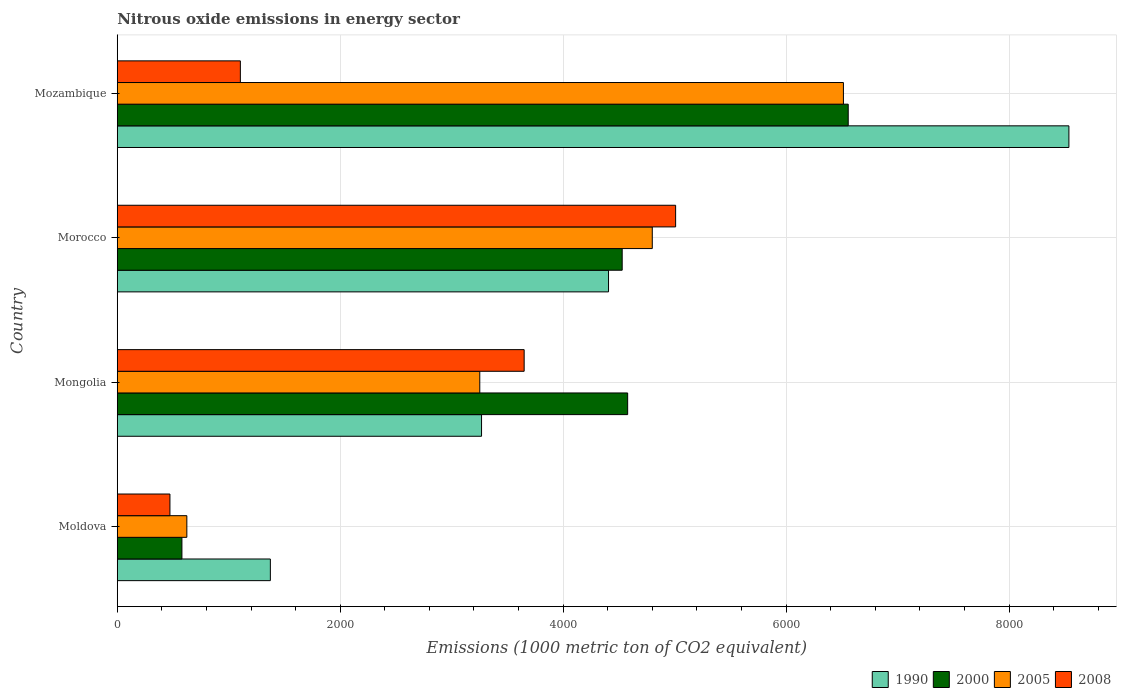Are the number of bars per tick equal to the number of legend labels?
Your answer should be compact. Yes. How many bars are there on the 3rd tick from the bottom?
Make the answer very short. 4. What is the label of the 1st group of bars from the top?
Provide a short and direct response. Mozambique. In how many cases, is the number of bars for a given country not equal to the number of legend labels?
Provide a succinct answer. 0. What is the amount of nitrous oxide emitted in 2008 in Moldova?
Your response must be concise. 472.4. Across all countries, what is the maximum amount of nitrous oxide emitted in 2005?
Your answer should be very brief. 6514.2. Across all countries, what is the minimum amount of nitrous oxide emitted in 1990?
Offer a terse response. 1373.3. In which country was the amount of nitrous oxide emitted in 2005 maximum?
Keep it short and to the point. Mozambique. In which country was the amount of nitrous oxide emitted in 1990 minimum?
Provide a short and direct response. Moldova. What is the total amount of nitrous oxide emitted in 2005 in the graph?
Offer a very short reply. 1.52e+04. What is the difference between the amount of nitrous oxide emitted in 1990 in Moldova and that in Mozambique?
Offer a terse response. -7163.7. What is the difference between the amount of nitrous oxide emitted in 2008 in Morocco and the amount of nitrous oxide emitted in 1990 in Mongolia?
Provide a short and direct response. 1741.1. What is the average amount of nitrous oxide emitted in 2000 per country?
Provide a short and direct response. 4061.3. What is the difference between the amount of nitrous oxide emitted in 1990 and amount of nitrous oxide emitted in 2000 in Mongolia?
Your response must be concise. -1310.8. What is the ratio of the amount of nitrous oxide emitted in 2008 in Mongolia to that in Morocco?
Keep it short and to the point. 0.73. Is the difference between the amount of nitrous oxide emitted in 1990 in Moldova and Mongolia greater than the difference between the amount of nitrous oxide emitted in 2000 in Moldova and Mongolia?
Your response must be concise. Yes. What is the difference between the highest and the second highest amount of nitrous oxide emitted in 2000?
Offer a very short reply. 1978.6. What is the difference between the highest and the lowest amount of nitrous oxide emitted in 2008?
Offer a very short reply. 4536.5. In how many countries, is the amount of nitrous oxide emitted in 2000 greater than the average amount of nitrous oxide emitted in 2000 taken over all countries?
Ensure brevity in your answer.  3. Is the sum of the amount of nitrous oxide emitted in 2008 in Moldova and Mozambique greater than the maximum amount of nitrous oxide emitted in 1990 across all countries?
Give a very brief answer. No. Is it the case that in every country, the sum of the amount of nitrous oxide emitted in 2000 and amount of nitrous oxide emitted in 1990 is greater than the sum of amount of nitrous oxide emitted in 2005 and amount of nitrous oxide emitted in 2008?
Provide a succinct answer. No. What does the 1st bar from the bottom in Moldova represents?
Make the answer very short. 1990. What is the difference between two consecutive major ticks on the X-axis?
Your response must be concise. 2000. Are the values on the major ticks of X-axis written in scientific E-notation?
Offer a terse response. No. Does the graph contain any zero values?
Ensure brevity in your answer.  No. Does the graph contain grids?
Offer a terse response. Yes. What is the title of the graph?
Make the answer very short. Nitrous oxide emissions in energy sector. What is the label or title of the X-axis?
Provide a short and direct response. Emissions (1000 metric ton of CO2 equivalent). What is the Emissions (1000 metric ton of CO2 equivalent) of 1990 in Moldova?
Offer a terse response. 1373.3. What is the Emissions (1000 metric ton of CO2 equivalent) in 2000 in Moldova?
Your response must be concise. 579.9. What is the Emissions (1000 metric ton of CO2 equivalent) of 2005 in Moldova?
Give a very brief answer. 624.1. What is the Emissions (1000 metric ton of CO2 equivalent) in 2008 in Moldova?
Give a very brief answer. 472.4. What is the Emissions (1000 metric ton of CO2 equivalent) of 1990 in Mongolia?
Provide a short and direct response. 3267.8. What is the Emissions (1000 metric ton of CO2 equivalent) of 2000 in Mongolia?
Your answer should be compact. 4578.6. What is the Emissions (1000 metric ton of CO2 equivalent) in 2005 in Mongolia?
Offer a very short reply. 3251.9. What is the Emissions (1000 metric ton of CO2 equivalent) in 2008 in Mongolia?
Make the answer very short. 3650.1. What is the Emissions (1000 metric ton of CO2 equivalent) of 1990 in Morocco?
Offer a very short reply. 4406.9. What is the Emissions (1000 metric ton of CO2 equivalent) of 2000 in Morocco?
Your answer should be very brief. 4529.5. What is the Emissions (1000 metric ton of CO2 equivalent) in 2005 in Morocco?
Your answer should be very brief. 4799.4. What is the Emissions (1000 metric ton of CO2 equivalent) in 2008 in Morocco?
Your answer should be very brief. 5008.9. What is the Emissions (1000 metric ton of CO2 equivalent) of 1990 in Mozambique?
Give a very brief answer. 8537. What is the Emissions (1000 metric ton of CO2 equivalent) in 2000 in Mozambique?
Keep it short and to the point. 6557.2. What is the Emissions (1000 metric ton of CO2 equivalent) in 2005 in Mozambique?
Give a very brief answer. 6514.2. What is the Emissions (1000 metric ton of CO2 equivalent) of 2008 in Mozambique?
Your response must be concise. 1104.1. Across all countries, what is the maximum Emissions (1000 metric ton of CO2 equivalent) of 1990?
Provide a short and direct response. 8537. Across all countries, what is the maximum Emissions (1000 metric ton of CO2 equivalent) of 2000?
Provide a short and direct response. 6557.2. Across all countries, what is the maximum Emissions (1000 metric ton of CO2 equivalent) in 2005?
Give a very brief answer. 6514.2. Across all countries, what is the maximum Emissions (1000 metric ton of CO2 equivalent) of 2008?
Give a very brief answer. 5008.9. Across all countries, what is the minimum Emissions (1000 metric ton of CO2 equivalent) in 1990?
Your response must be concise. 1373.3. Across all countries, what is the minimum Emissions (1000 metric ton of CO2 equivalent) of 2000?
Provide a short and direct response. 579.9. Across all countries, what is the minimum Emissions (1000 metric ton of CO2 equivalent) of 2005?
Offer a very short reply. 624.1. Across all countries, what is the minimum Emissions (1000 metric ton of CO2 equivalent) of 2008?
Keep it short and to the point. 472.4. What is the total Emissions (1000 metric ton of CO2 equivalent) of 1990 in the graph?
Make the answer very short. 1.76e+04. What is the total Emissions (1000 metric ton of CO2 equivalent) of 2000 in the graph?
Provide a short and direct response. 1.62e+04. What is the total Emissions (1000 metric ton of CO2 equivalent) in 2005 in the graph?
Your answer should be compact. 1.52e+04. What is the total Emissions (1000 metric ton of CO2 equivalent) of 2008 in the graph?
Your answer should be compact. 1.02e+04. What is the difference between the Emissions (1000 metric ton of CO2 equivalent) of 1990 in Moldova and that in Mongolia?
Offer a terse response. -1894.5. What is the difference between the Emissions (1000 metric ton of CO2 equivalent) in 2000 in Moldova and that in Mongolia?
Make the answer very short. -3998.7. What is the difference between the Emissions (1000 metric ton of CO2 equivalent) in 2005 in Moldova and that in Mongolia?
Your response must be concise. -2627.8. What is the difference between the Emissions (1000 metric ton of CO2 equivalent) in 2008 in Moldova and that in Mongolia?
Your answer should be compact. -3177.7. What is the difference between the Emissions (1000 metric ton of CO2 equivalent) of 1990 in Moldova and that in Morocco?
Offer a very short reply. -3033.6. What is the difference between the Emissions (1000 metric ton of CO2 equivalent) of 2000 in Moldova and that in Morocco?
Your answer should be compact. -3949.6. What is the difference between the Emissions (1000 metric ton of CO2 equivalent) of 2005 in Moldova and that in Morocco?
Give a very brief answer. -4175.3. What is the difference between the Emissions (1000 metric ton of CO2 equivalent) in 2008 in Moldova and that in Morocco?
Make the answer very short. -4536.5. What is the difference between the Emissions (1000 metric ton of CO2 equivalent) in 1990 in Moldova and that in Mozambique?
Give a very brief answer. -7163.7. What is the difference between the Emissions (1000 metric ton of CO2 equivalent) of 2000 in Moldova and that in Mozambique?
Your answer should be compact. -5977.3. What is the difference between the Emissions (1000 metric ton of CO2 equivalent) in 2005 in Moldova and that in Mozambique?
Your response must be concise. -5890.1. What is the difference between the Emissions (1000 metric ton of CO2 equivalent) of 2008 in Moldova and that in Mozambique?
Offer a very short reply. -631.7. What is the difference between the Emissions (1000 metric ton of CO2 equivalent) in 1990 in Mongolia and that in Morocco?
Offer a terse response. -1139.1. What is the difference between the Emissions (1000 metric ton of CO2 equivalent) in 2000 in Mongolia and that in Morocco?
Offer a very short reply. 49.1. What is the difference between the Emissions (1000 metric ton of CO2 equivalent) of 2005 in Mongolia and that in Morocco?
Provide a succinct answer. -1547.5. What is the difference between the Emissions (1000 metric ton of CO2 equivalent) of 2008 in Mongolia and that in Morocco?
Your response must be concise. -1358.8. What is the difference between the Emissions (1000 metric ton of CO2 equivalent) of 1990 in Mongolia and that in Mozambique?
Your answer should be compact. -5269.2. What is the difference between the Emissions (1000 metric ton of CO2 equivalent) in 2000 in Mongolia and that in Mozambique?
Your answer should be very brief. -1978.6. What is the difference between the Emissions (1000 metric ton of CO2 equivalent) of 2005 in Mongolia and that in Mozambique?
Give a very brief answer. -3262.3. What is the difference between the Emissions (1000 metric ton of CO2 equivalent) in 2008 in Mongolia and that in Mozambique?
Provide a succinct answer. 2546. What is the difference between the Emissions (1000 metric ton of CO2 equivalent) of 1990 in Morocco and that in Mozambique?
Give a very brief answer. -4130.1. What is the difference between the Emissions (1000 metric ton of CO2 equivalent) in 2000 in Morocco and that in Mozambique?
Give a very brief answer. -2027.7. What is the difference between the Emissions (1000 metric ton of CO2 equivalent) in 2005 in Morocco and that in Mozambique?
Your response must be concise. -1714.8. What is the difference between the Emissions (1000 metric ton of CO2 equivalent) of 2008 in Morocco and that in Mozambique?
Make the answer very short. 3904.8. What is the difference between the Emissions (1000 metric ton of CO2 equivalent) of 1990 in Moldova and the Emissions (1000 metric ton of CO2 equivalent) of 2000 in Mongolia?
Give a very brief answer. -3205.3. What is the difference between the Emissions (1000 metric ton of CO2 equivalent) of 1990 in Moldova and the Emissions (1000 metric ton of CO2 equivalent) of 2005 in Mongolia?
Give a very brief answer. -1878.6. What is the difference between the Emissions (1000 metric ton of CO2 equivalent) in 1990 in Moldova and the Emissions (1000 metric ton of CO2 equivalent) in 2008 in Mongolia?
Provide a short and direct response. -2276.8. What is the difference between the Emissions (1000 metric ton of CO2 equivalent) in 2000 in Moldova and the Emissions (1000 metric ton of CO2 equivalent) in 2005 in Mongolia?
Provide a short and direct response. -2672. What is the difference between the Emissions (1000 metric ton of CO2 equivalent) of 2000 in Moldova and the Emissions (1000 metric ton of CO2 equivalent) of 2008 in Mongolia?
Your answer should be compact. -3070.2. What is the difference between the Emissions (1000 metric ton of CO2 equivalent) in 2005 in Moldova and the Emissions (1000 metric ton of CO2 equivalent) in 2008 in Mongolia?
Your answer should be compact. -3026. What is the difference between the Emissions (1000 metric ton of CO2 equivalent) of 1990 in Moldova and the Emissions (1000 metric ton of CO2 equivalent) of 2000 in Morocco?
Provide a short and direct response. -3156.2. What is the difference between the Emissions (1000 metric ton of CO2 equivalent) in 1990 in Moldova and the Emissions (1000 metric ton of CO2 equivalent) in 2005 in Morocco?
Offer a very short reply. -3426.1. What is the difference between the Emissions (1000 metric ton of CO2 equivalent) of 1990 in Moldova and the Emissions (1000 metric ton of CO2 equivalent) of 2008 in Morocco?
Provide a succinct answer. -3635.6. What is the difference between the Emissions (1000 metric ton of CO2 equivalent) in 2000 in Moldova and the Emissions (1000 metric ton of CO2 equivalent) in 2005 in Morocco?
Keep it short and to the point. -4219.5. What is the difference between the Emissions (1000 metric ton of CO2 equivalent) in 2000 in Moldova and the Emissions (1000 metric ton of CO2 equivalent) in 2008 in Morocco?
Keep it short and to the point. -4429. What is the difference between the Emissions (1000 metric ton of CO2 equivalent) in 2005 in Moldova and the Emissions (1000 metric ton of CO2 equivalent) in 2008 in Morocco?
Your response must be concise. -4384.8. What is the difference between the Emissions (1000 metric ton of CO2 equivalent) of 1990 in Moldova and the Emissions (1000 metric ton of CO2 equivalent) of 2000 in Mozambique?
Provide a short and direct response. -5183.9. What is the difference between the Emissions (1000 metric ton of CO2 equivalent) in 1990 in Moldova and the Emissions (1000 metric ton of CO2 equivalent) in 2005 in Mozambique?
Ensure brevity in your answer.  -5140.9. What is the difference between the Emissions (1000 metric ton of CO2 equivalent) in 1990 in Moldova and the Emissions (1000 metric ton of CO2 equivalent) in 2008 in Mozambique?
Keep it short and to the point. 269.2. What is the difference between the Emissions (1000 metric ton of CO2 equivalent) of 2000 in Moldova and the Emissions (1000 metric ton of CO2 equivalent) of 2005 in Mozambique?
Your answer should be compact. -5934.3. What is the difference between the Emissions (1000 metric ton of CO2 equivalent) in 2000 in Moldova and the Emissions (1000 metric ton of CO2 equivalent) in 2008 in Mozambique?
Ensure brevity in your answer.  -524.2. What is the difference between the Emissions (1000 metric ton of CO2 equivalent) of 2005 in Moldova and the Emissions (1000 metric ton of CO2 equivalent) of 2008 in Mozambique?
Provide a short and direct response. -480. What is the difference between the Emissions (1000 metric ton of CO2 equivalent) of 1990 in Mongolia and the Emissions (1000 metric ton of CO2 equivalent) of 2000 in Morocco?
Keep it short and to the point. -1261.7. What is the difference between the Emissions (1000 metric ton of CO2 equivalent) of 1990 in Mongolia and the Emissions (1000 metric ton of CO2 equivalent) of 2005 in Morocco?
Provide a succinct answer. -1531.6. What is the difference between the Emissions (1000 metric ton of CO2 equivalent) of 1990 in Mongolia and the Emissions (1000 metric ton of CO2 equivalent) of 2008 in Morocco?
Your response must be concise. -1741.1. What is the difference between the Emissions (1000 metric ton of CO2 equivalent) of 2000 in Mongolia and the Emissions (1000 metric ton of CO2 equivalent) of 2005 in Morocco?
Keep it short and to the point. -220.8. What is the difference between the Emissions (1000 metric ton of CO2 equivalent) in 2000 in Mongolia and the Emissions (1000 metric ton of CO2 equivalent) in 2008 in Morocco?
Give a very brief answer. -430.3. What is the difference between the Emissions (1000 metric ton of CO2 equivalent) of 2005 in Mongolia and the Emissions (1000 metric ton of CO2 equivalent) of 2008 in Morocco?
Your response must be concise. -1757. What is the difference between the Emissions (1000 metric ton of CO2 equivalent) in 1990 in Mongolia and the Emissions (1000 metric ton of CO2 equivalent) in 2000 in Mozambique?
Offer a terse response. -3289.4. What is the difference between the Emissions (1000 metric ton of CO2 equivalent) in 1990 in Mongolia and the Emissions (1000 metric ton of CO2 equivalent) in 2005 in Mozambique?
Your response must be concise. -3246.4. What is the difference between the Emissions (1000 metric ton of CO2 equivalent) of 1990 in Mongolia and the Emissions (1000 metric ton of CO2 equivalent) of 2008 in Mozambique?
Give a very brief answer. 2163.7. What is the difference between the Emissions (1000 metric ton of CO2 equivalent) of 2000 in Mongolia and the Emissions (1000 metric ton of CO2 equivalent) of 2005 in Mozambique?
Ensure brevity in your answer.  -1935.6. What is the difference between the Emissions (1000 metric ton of CO2 equivalent) of 2000 in Mongolia and the Emissions (1000 metric ton of CO2 equivalent) of 2008 in Mozambique?
Provide a short and direct response. 3474.5. What is the difference between the Emissions (1000 metric ton of CO2 equivalent) of 2005 in Mongolia and the Emissions (1000 metric ton of CO2 equivalent) of 2008 in Mozambique?
Your answer should be compact. 2147.8. What is the difference between the Emissions (1000 metric ton of CO2 equivalent) in 1990 in Morocco and the Emissions (1000 metric ton of CO2 equivalent) in 2000 in Mozambique?
Keep it short and to the point. -2150.3. What is the difference between the Emissions (1000 metric ton of CO2 equivalent) in 1990 in Morocco and the Emissions (1000 metric ton of CO2 equivalent) in 2005 in Mozambique?
Offer a terse response. -2107.3. What is the difference between the Emissions (1000 metric ton of CO2 equivalent) of 1990 in Morocco and the Emissions (1000 metric ton of CO2 equivalent) of 2008 in Mozambique?
Your answer should be very brief. 3302.8. What is the difference between the Emissions (1000 metric ton of CO2 equivalent) in 2000 in Morocco and the Emissions (1000 metric ton of CO2 equivalent) in 2005 in Mozambique?
Keep it short and to the point. -1984.7. What is the difference between the Emissions (1000 metric ton of CO2 equivalent) in 2000 in Morocco and the Emissions (1000 metric ton of CO2 equivalent) in 2008 in Mozambique?
Provide a succinct answer. 3425.4. What is the difference between the Emissions (1000 metric ton of CO2 equivalent) of 2005 in Morocco and the Emissions (1000 metric ton of CO2 equivalent) of 2008 in Mozambique?
Your response must be concise. 3695.3. What is the average Emissions (1000 metric ton of CO2 equivalent) of 1990 per country?
Offer a terse response. 4396.25. What is the average Emissions (1000 metric ton of CO2 equivalent) in 2000 per country?
Give a very brief answer. 4061.3. What is the average Emissions (1000 metric ton of CO2 equivalent) in 2005 per country?
Offer a very short reply. 3797.4. What is the average Emissions (1000 metric ton of CO2 equivalent) of 2008 per country?
Keep it short and to the point. 2558.88. What is the difference between the Emissions (1000 metric ton of CO2 equivalent) in 1990 and Emissions (1000 metric ton of CO2 equivalent) in 2000 in Moldova?
Ensure brevity in your answer.  793.4. What is the difference between the Emissions (1000 metric ton of CO2 equivalent) of 1990 and Emissions (1000 metric ton of CO2 equivalent) of 2005 in Moldova?
Your response must be concise. 749.2. What is the difference between the Emissions (1000 metric ton of CO2 equivalent) of 1990 and Emissions (1000 metric ton of CO2 equivalent) of 2008 in Moldova?
Your answer should be compact. 900.9. What is the difference between the Emissions (1000 metric ton of CO2 equivalent) in 2000 and Emissions (1000 metric ton of CO2 equivalent) in 2005 in Moldova?
Your answer should be very brief. -44.2. What is the difference between the Emissions (1000 metric ton of CO2 equivalent) of 2000 and Emissions (1000 metric ton of CO2 equivalent) of 2008 in Moldova?
Ensure brevity in your answer.  107.5. What is the difference between the Emissions (1000 metric ton of CO2 equivalent) in 2005 and Emissions (1000 metric ton of CO2 equivalent) in 2008 in Moldova?
Your response must be concise. 151.7. What is the difference between the Emissions (1000 metric ton of CO2 equivalent) in 1990 and Emissions (1000 metric ton of CO2 equivalent) in 2000 in Mongolia?
Keep it short and to the point. -1310.8. What is the difference between the Emissions (1000 metric ton of CO2 equivalent) of 1990 and Emissions (1000 metric ton of CO2 equivalent) of 2005 in Mongolia?
Keep it short and to the point. 15.9. What is the difference between the Emissions (1000 metric ton of CO2 equivalent) of 1990 and Emissions (1000 metric ton of CO2 equivalent) of 2008 in Mongolia?
Keep it short and to the point. -382.3. What is the difference between the Emissions (1000 metric ton of CO2 equivalent) of 2000 and Emissions (1000 metric ton of CO2 equivalent) of 2005 in Mongolia?
Your answer should be compact. 1326.7. What is the difference between the Emissions (1000 metric ton of CO2 equivalent) in 2000 and Emissions (1000 metric ton of CO2 equivalent) in 2008 in Mongolia?
Provide a succinct answer. 928.5. What is the difference between the Emissions (1000 metric ton of CO2 equivalent) of 2005 and Emissions (1000 metric ton of CO2 equivalent) of 2008 in Mongolia?
Provide a succinct answer. -398.2. What is the difference between the Emissions (1000 metric ton of CO2 equivalent) of 1990 and Emissions (1000 metric ton of CO2 equivalent) of 2000 in Morocco?
Offer a terse response. -122.6. What is the difference between the Emissions (1000 metric ton of CO2 equivalent) in 1990 and Emissions (1000 metric ton of CO2 equivalent) in 2005 in Morocco?
Give a very brief answer. -392.5. What is the difference between the Emissions (1000 metric ton of CO2 equivalent) of 1990 and Emissions (1000 metric ton of CO2 equivalent) of 2008 in Morocco?
Provide a short and direct response. -602. What is the difference between the Emissions (1000 metric ton of CO2 equivalent) in 2000 and Emissions (1000 metric ton of CO2 equivalent) in 2005 in Morocco?
Ensure brevity in your answer.  -269.9. What is the difference between the Emissions (1000 metric ton of CO2 equivalent) of 2000 and Emissions (1000 metric ton of CO2 equivalent) of 2008 in Morocco?
Your response must be concise. -479.4. What is the difference between the Emissions (1000 metric ton of CO2 equivalent) of 2005 and Emissions (1000 metric ton of CO2 equivalent) of 2008 in Morocco?
Your answer should be compact. -209.5. What is the difference between the Emissions (1000 metric ton of CO2 equivalent) in 1990 and Emissions (1000 metric ton of CO2 equivalent) in 2000 in Mozambique?
Offer a very short reply. 1979.8. What is the difference between the Emissions (1000 metric ton of CO2 equivalent) in 1990 and Emissions (1000 metric ton of CO2 equivalent) in 2005 in Mozambique?
Your answer should be very brief. 2022.8. What is the difference between the Emissions (1000 metric ton of CO2 equivalent) in 1990 and Emissions (1000 metric ton of CO2 equivalent) in 2008 in Mozambique?
Keep it short and to the point. 7432.9. What is the difference between the Emissions (1000 metric ton of CO2 equivalent) of 2000 and Emissions (1000 metric ton of CO2 equivalent) of 2005 in Mozambique?
Make the answer very short. 43. What is the difference between the Emissions (1000 metric ton of CO2 equivalent) of 2000 and Emissions (1000 metric ton of CO2 equivalent) of 2008 in Mozambique?
Offer a terse response. 5453.1. What is the difference between the Emissions (1000 metric ton of CO2 equivalent) in 2005 and Emissions (1000 metric ton of CO2 equivalent) in 2008 in Mozambique?
Give a very brief answer. 5410.1. What is the ratio of the Emissions (1000 metric ton of CO2 equivalent) in 1990 in Moldova to that in Mongolia?
Your answer should be compact. 0.42. What is the ratio of the Emissions (1000 metric ton of CO2 equivalent) in 2000 in Moldova to that in Mongolia?
Provide a succinct answer. 0.13. What is the ratio of the Emissions (1000 metric ton of CO2 equivalent) in 2005 in Moldova to that in Mongolia?
Make the answer very short. 0.19. What is the ratio of the Emissions (1000 metric ton of CO2 equivalent) in 2008 in Moldova to that in Mongolia?
Make the answer very short. 0.13. What is the ratio of the Emissions (1000 metric ton of CO2 equivalent) of 1990 in Moldova to that in Morocco?
Ensure brevity in your answer.  0.31. What is the ratio of the Emissions (1000 metric ton of CO2 equivalent) of 2000 in Moldova to that in Morocco?
Offer a very short reply. 0.13. What is the ratio of the Emissions (1000 metric ton of CO2 equivalent) of 2005 in Moldova to that in Morocco?
Offer a very short reply. 0.13. What is the ratio of the Emissions (1000 metric ton of CO2 equivalent) in 2008 in Moldova to that in Morocco?
Your answer should be very brief. 0.09. What is the ratio of the Emissions (1000 metric ton of CO2 equivalent) of 1990 in Moldova to that in Mozambique?
Provide a short and direct response. 0.16. What is the ratio of the Emissions (1000 metric ton of CO2 equivalent) in 2000 in Moldova to that in Mozambique?
Provide a succinct answer. 0.09. What is the ratio of the Emissions (1000 metric ton of CO2 equivalent) of 2005 in Moldova to that in Mozambique?
Your answer should be compact. 0.1. What is the ratio of the Emissions (1000 metric ton of CO2 equivalent) of 2008 in Moldova to that in Mozambique?
Offer a very short reply. 0.43. What is the ratio of the Emissions (1000 metric ton of CO2 equivalent) in 1990 in Mongolia to that in Morocco?
Offer a terse response. 0.74. What is the ratio of the Emissions (1000 metric ton of CO2 equivalent) in 2000 in Mongolia to that in Morocco?
Make the answer very short. 1.01. What is the ratio of the Emissions (1000 metric ton of CO2 equivalent) in 2005 in Mongolia to that in Morocco?
Keep it short and to the point. 0.68. What is the ratio of the Emissions (1000 metric ton of CO2 equivalent) of 2008 in Mongolia to that in Morocco?
Ensure brevity in your answer.  0.73. What is the ratio of the Emissions (1000 metric ton of CO2 equivalent) in 1990 in Mongolia to that in Mozambique?
Provide a short and direct response. 0.38. What is the ratio of the Emissions (1000 metric ton of CO2 equivalent) in 2000 in Mongolia to that in Mozambique?
Your answer should be compact. 0.7. What is the ratio of the Emissions (1000 metric ton of CO2 equivalent) in 2005 in Mongolia to that in Mozambique?
Your answer should be compact. 0.5. What is the ratio of the Emissions (1000 metric ton of CO2 equivalent) of 2008 in Mongolia to that in Mozambique?
Your response must be concise. 3.31. What is the ratio of the Emissions (1000 metric ton of CO2 equivalent) in 1990 in Morocco to that in Mozambique?
Your answer should be compact. 0.52. What is the ratio of the Emissions (1000 metric ton of CO2 equivalent) in 2000 in Morocco to that in Mozambique?
Keep it short and to the point. 0.69. What is the ratio of the Emissions (1000 metric ton of CO2 equivalent) in 2005 in Morocco to that in Mozambique?
Keep it short and to the point. 0.74. What is the ratio of the Emissions (1000 metric ton of CO2 equivalent) of 2008 in Morocco to that in Mozambique?
Provide a short and direct response. 4.54. What is the difference between the highest and the second highest Emissions (1000 metric ton of CO2 equivalent) in 1990?
Your response must be concise. 4130.1. What is the difference between the highest and the second highest Emissions (1000 metric ton of CO2 equivalent) in 2000?
Your answer should be compact. 1978.6. What is the difference between the highest and the second highest Emissions (1000 metric ton of CO2 equivalent) of 2005?
Keep it short and to the point. 1714.8. What is the difference between the highest and the second highest Emissions (1000 metric ton of CO2 equivalent) in 2008?
Make the answer very short. 1358.8. What is the difference between the highest and the lowest Emissions (1000 metric ton of CO2 equivalent) of 1990?
Your response must be concise. 7163.7. What is the difference between the highest and the lowest Emissions (1000 metric ton of CO2 equivalent) in 2000?
Give a very brief answer. 5977.3. What is the difference between the highest and the lowest Emissions (1000 metric ton of CO2 equivalent) in 2005?
Provide a succinct answer. 5890.1. What is the difference between the highest and the lowest Emissions (1000 metric ton of CO2 equivalent) of 2008?
Your response must be concise. 4536.5. 